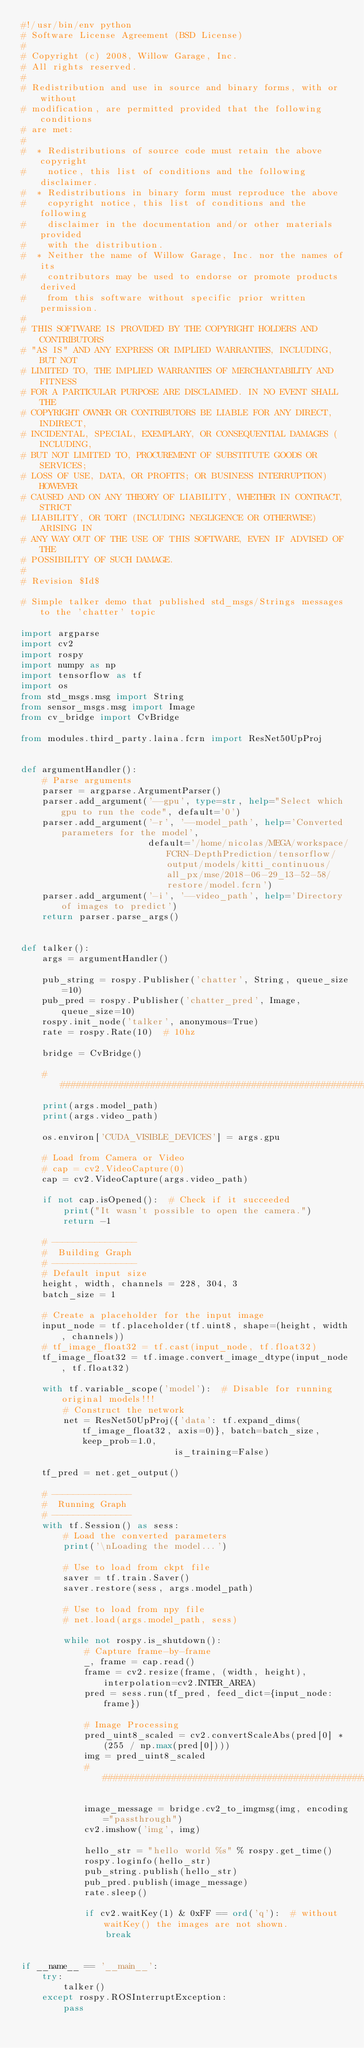Convert code to text. <code><loc_0><loc_0><loc_500><loc_500><_Python_>#!/usr/bin/env python
# Software License Agreement (BSD License)
#
# Copyright (c) 2008, Willow Garage, Inc.
# All rights reserved.
#
# Redistribution and use in source and binary forms, with or without
# modification, are permitted provided that the following conditions
# are met:
#
#  * Redistributions of source code must retain the above copyright
#    notice, this list of conditions and the following disclaimer.
#  * Redistributions in binary form must reproduce the above
#    copyright notice, this list of conditions and the following
#    disclaimer in the documentation and/or other materials provided
#    with the distribution.
#  * Neither the name of Willow Garage, Inc. nor the names of its
#    contributors may be used to endorse or promote products derived
#    from this software without specific prior written permission.
#
# THIS SOFTWARE IS PROVIDED BY THE COPYRIGHT HOLDERS AND CONTRIBUTORS
# "AS IS" AND ANY EXPRESS OR IMPLIED WARRANTIES, INCLUDING, BUT NOT
# LIMITED TO, THE IMPLIED WARRANTIES OF MERCHANTABILITY AND FITNESS
# FOR A PARTICULAR PURPOSE ARE DISCLAIMED. IN NO EVENT SHALL THE
# COPYRIGHT OWNER OR CONTRIBUTORS BE LIABLE FOR ANY DIRECT, INDIRECT,
# INCIDENTAL, SPECIAL, EXEMPLARY, OR CONSEQUENTIAL DAMAGES (INCLUDING,
# BUT NOT LIMITED TO, PROCUREMENT OF SUBSTITUTE GOODS OR SERVICES;
# LOSS OF USE, DATA, OR PROFITS; OR BUSINESS INTERRUPTION) HOWEVER
# CAUSED AND ON ANY THEORY OF LIABILITY, WHETHER IN CONTRACT, STRICT
# LIABILITY, OR TORT (INCLUDING NEGLIGENCE OR OTHERWISE) ARISING IN
# ANY WAY OUT OF THE USE OF THIS SOFTWARE, EVEN IF ADVISED OF THE
# POSSIBILITY OF SUCH DAMAGE.
#
# Revision $Id$

# Simple talker demo that published std_msgs/Strings messages to the 'chatter' topic

import argparse
import cv2
import rospy
import numpy as np
import tensorflow as tf
import os
from std_msgs.msg import String
from sensor_msgs.msg import Image
from cv_bridge import CvBridge

from modules.third_party.laina.fcrn import ResNet50UpProj


def argumentHandler():
    # Parse arguments
    parser = argparse.ArgumentParser()
    parser.add_argument('--gpu', type=str, help="Select which gpu to run the code", default='0')
    parser.add_argument('-r', '--model_path', help='Converted parameters for the model',
                        default='/home/nicolas/MEGA/workspace/FCRN-DepthPrediction/tensorflow/output/models/kitti_continuous/all_px/mse/2018-06-29_13-52-58/restore/model.fcrn')
    parser.add_argument('-i', '--video_path', help='Directory of images to predict')
    return parser.parse_args()


def talker():
    args = argumentHandler()

    pub_string = rospy.Publisher('chatter', String, queue_size=10)
    pub_pred = rospy.Publisher('chatter_pred', Image, queue_size=10)
    rospy.init_node('talker', anonymous=True)
    rate = rospy.Rate(10)  # 10hz

    bridge = CvBridge()

    ###############################################################################
    print(args.model_path)
    print(args.video_path)

    os.environ['CUDA_VISIBLE_DEVICES'] = args.gpu

    # Load from Camera or Video
    # cap = cv2.VideoCapture(0)
    cap = cv2.VideoCapture(args.video_path)

    if not cap.isOpened():  # Check if it succeeded
        print("It wasn't possible to open the camera.")
        return -1

    # ----------------
    #  Building Graph
    # ----------------
    # Default input size
    height, width, channels = 228, 304, 3
    batch_size = 1

    # Create a placeholder for the input image
    input_node = tf.placeholder(tf.uint8, shape=(height, width, channels))
    # tf_image_float32 = tf.cast(input_node, tf.float32)
    tf_image_float32 = tf.image.convert_image_dtype(input_node, tf.float32)

    with tf.variable_scope('model'):  # Disable for running original models!!!
        # Construct the network
        net = ResNet50UpProj({'data': tf.expand_dims(tf_image_float32, axis=0)}, batch=batch_size, keep_prob=1.0,
                             is_training=False)

    tf_pred = net.get_output()

    # ---------------
    #  Running Graph
    # ---------------
    with tf.Session() as sess:
        # Load the converted parameters
        print('\nLoading the model...')

        # Use to load from ckpt file
        saver = tf.train.Saver()
        saver.restore(sess, args.model_path)

        # Use to load from npy file
        # net.load(args.model_path, sess)

        while not rospy.is_shutdown():
            # Capture frame-by-frame
            _, frame = cap.read()
            frame = cv2.resize(frame, (width, height), interpolation=cv2.INTER_AREA)
            pred = sess.run(tf_pred, feed_dict={input_node: frame})

            # Image Processing
            pred_uint8_scaled = cv2.convertScaleAbs(pred[0] * (255 / np.max(pred[0])))
            img = pred_uint8_scaled
            ###############################################################################

            image_message = bridge.cv2_to_imgmsg(img, encoding="passthrough")
            cv2.imshow('img', img)

            hello_str = "hello world %s" % rospy.get_time()
            rospy.loginfo(hello_str)
            pub_string.publish(hello_str)
            pub_pred.publish(image_message)
            rate.sleep()

            if cv2.waitKey(1) & 0xFF == ord('q'):  # without waitKey() the images are not shown.
                break


if __name__ == '__main__':
    try:
        talker()
    except rospy.ROSInterruptException:
        pass
</code> 